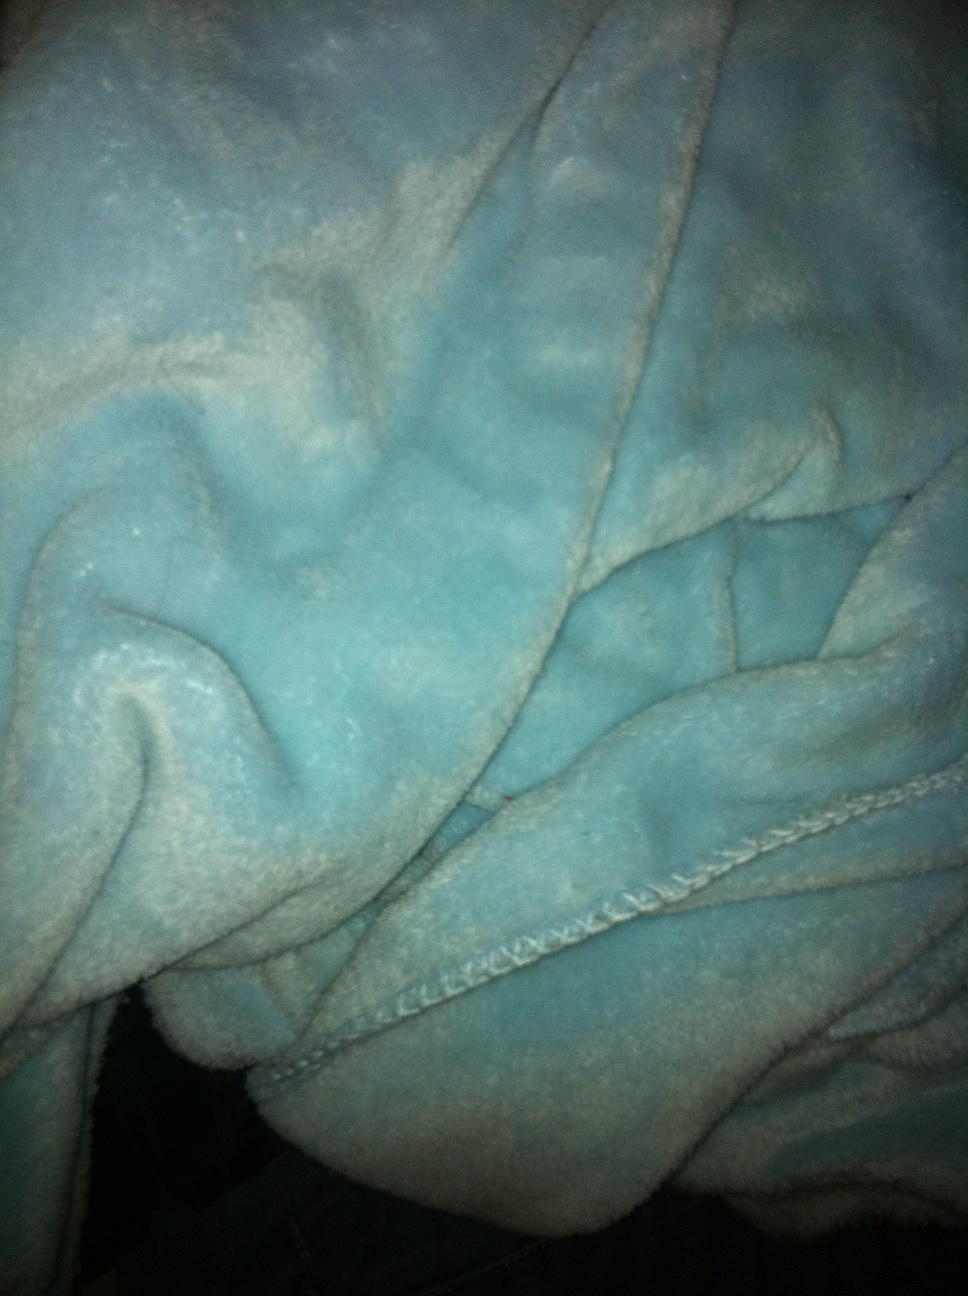Could you describe the texture of the material seen in the photo? Certainly! The material of the bathrobe appears to have a soft, velvety texture with a sheen that suggests it's plush and comfortable to the touch. The raised patterns give it a luxurious feel, indicative of a high-quality fabric designed for warmth and comfort. 